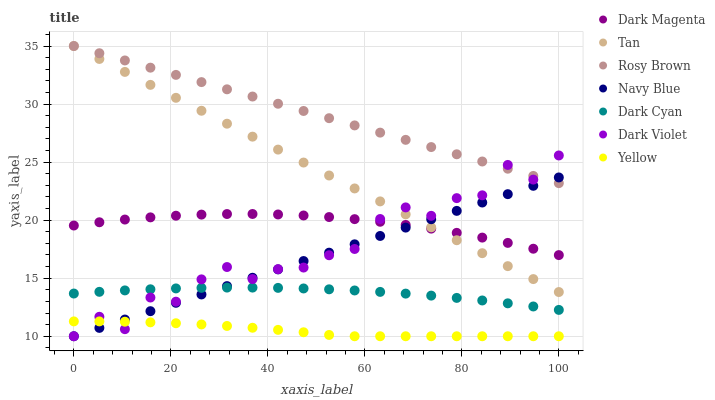Does Yellow have the minimum area under the curve?
Answer yes or no. Yes. Does Rosy Brown have the maximum area under the curve?
Answer yes or no. Yes. Does Navy Blue have the minimum area under the curve?
Answer yes or no. No. Does Navy Blue have the maximum area under the curve?
Answer yes or no. No. Is Tan the smoothest?
Answer yes or no. Yes. Is Dark Violet the roughest?
Answer yes or no. Yes. Is Navy Blue the smoothest?
Answer yes or no. No. Is Navy Blue the roughest?
Answer yes or no. No. Does Navy Blue have the lowest value?
Answer yes or no. Yes. Does Rosy Brown have the lowest value?
Answer yes or no. No. Does Tan have the highest value?
Answer yes or no. Yes. Does Navy Blue have the highest value?
Answer yes or no. No. Is Yellow less than Tan?
Answer yes or no. Yes. Is Dark Magenta greater than Dark Cyan?
Answer yes or no. Yes. Does Dark Violet intersect Yellow?
Answer yes or no. Yes. Is Dark Violet less than Yellow?
Answer yes or no. No. Is Dark Violet greater than Yellow?
Answer yes or no. No. Does Yellow intersect Tan?
Answer yes or no. No. 